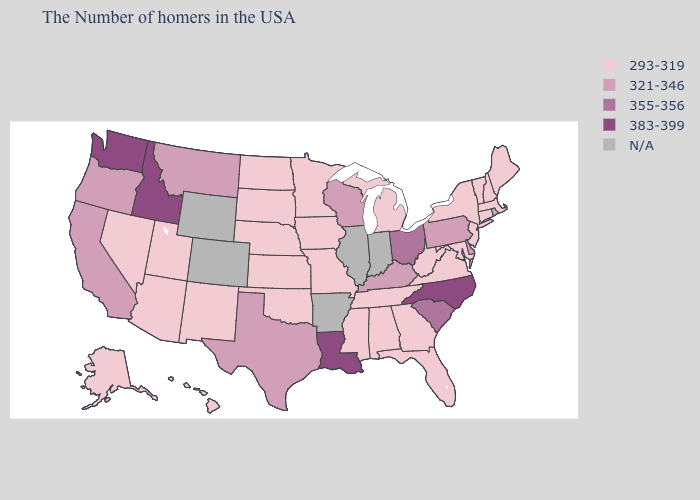What is the lowest value in the Northeast?
Short answer required. 293-319. What is the value of Delaware?
Keep it brief. 321-346. Among the states that border Virginia , does North Carolina have the lowest value?
Quick response, please. No. Among the states that border Missouri , which have the lowest value?
Give a very brief answer. Tennessee, Iowa, Kansas, Nebraska, Oklahoma. What is the highest value in the USA?
Answer briefly. 383-399. Does South Dakota have the highest value in the USA?
Quick response, please. No. Among the states that border Texas , which have the lowest value?
Short answer required. Oklahoma, New Mexico. Among the states that border North Dakota , which have the highest value?
Give a very brief answer. Montana. Is the legend a continuous bar?
Answer briefly. No. Name the states that have a value in the range 383-399?
Write a very short answer. North Carolina, Louisiana, Idaho, Washington. Does Minnesota have the lowest value in the MidWest?
Keep it brief. Yes. Is the legend a continuous bar?
Be succinct. No. Among the states that border Wyoming , does Idaho have the lowest value?
Give a very brief answer. No. 